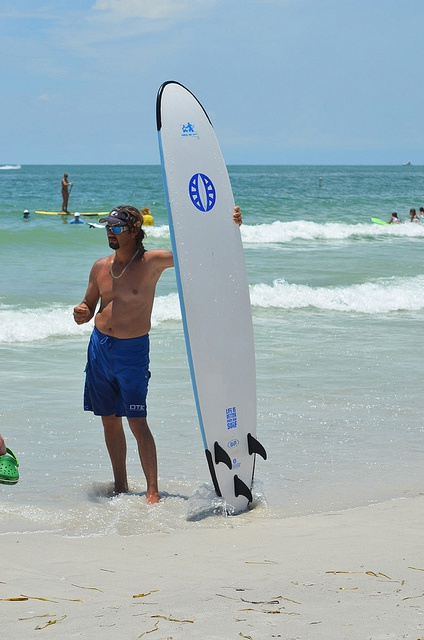Describe the objects in this image and their specific colors. I can see surfboard in lightblue, darkgray, and lightgray tones, people in lightblue, navy, maroon, black, and brown tones, people in lightblue, darkgreen, green, and gray tones, people in lightblue, black, and gray tones, and surfboard in lightblue, khaki, gray, and olive tones in this image. 